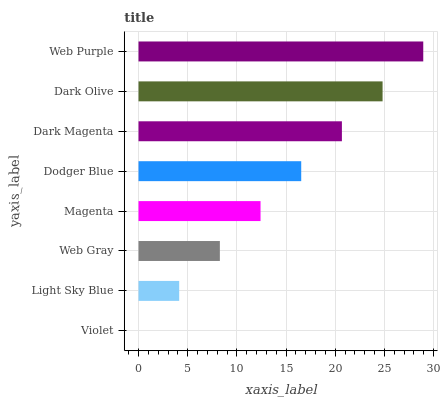Is Violet the minimum?
Answer yes or no. Yes. Is Web Purple the maximum?
Answer yes or no. Yes. Is Light Sky Blue the minimum?
Answer yes or no. No. Is Light Sky Blue the maximum?
Answer yes or no. No. Is Light Sky Blue greater than Violet?
Answer yes or no. Yes. Is Violet less than Light Sky Blue?
Answer yes or no. Yes. Is Violet greater than Light Sky Blue?
Answer yes or no. No. Is Light Sky Blue less than Violet?
Answer yes or no. No. Is Dodger Blue the high median?
Answer yes or no. Yes. Is Magenta the low median?
Answer yes or no. Yes. Is Violet the high median?
Answer yes or no. No. Is Violet the low median?
Answer yes or no. No. 